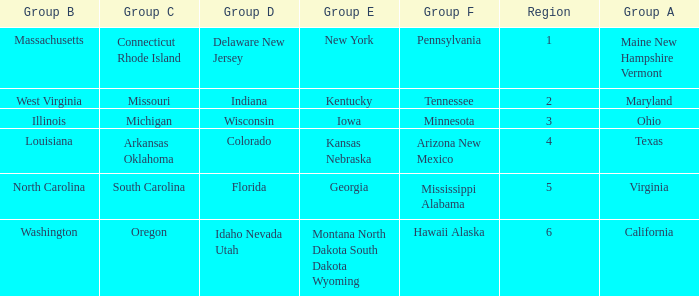What is the group C region with Illinois as group B? Michigan. 